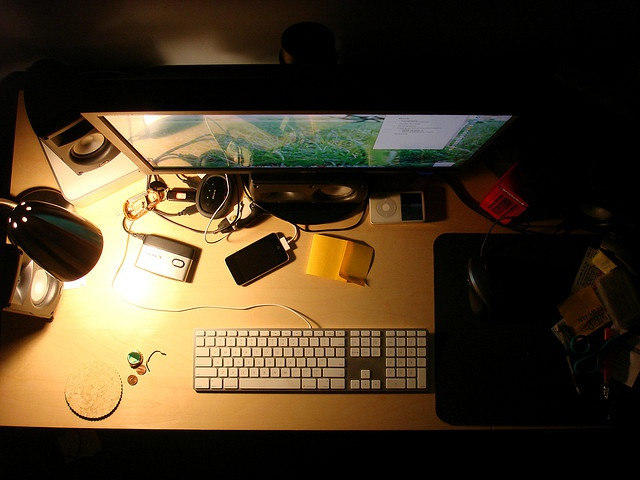Describe the objects in this image and their specific colors. I can see tv in black, gray, and tan tones, keyboard in black, tan, and olive tones, mouse in black, gray, and maroon tones, and cell phone in black, maroon, and olive tones in this image. 